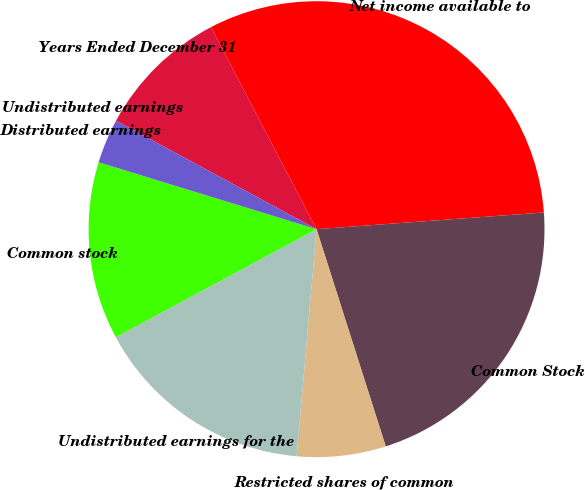Convert chart. <chart><loc_0><loc_0><loc_500><loc_500><pie_chart><fcel>Years Ended December 31<fcel>Net income available to<fcel>Common Stock<fcel>Restricted shares of common<fcel>Undistributed earnings for the<fcel>Common stock<fcel>Distributed earnings<fcel>Undistributed earnings<nl><fcel>9.45%<fcel>31.49%<fcel>21.26%<fcel>6.3%<fcel>15.75%<fcel>12.6%<fcel>3.15%<fcel>0.0%<nl></chart> 